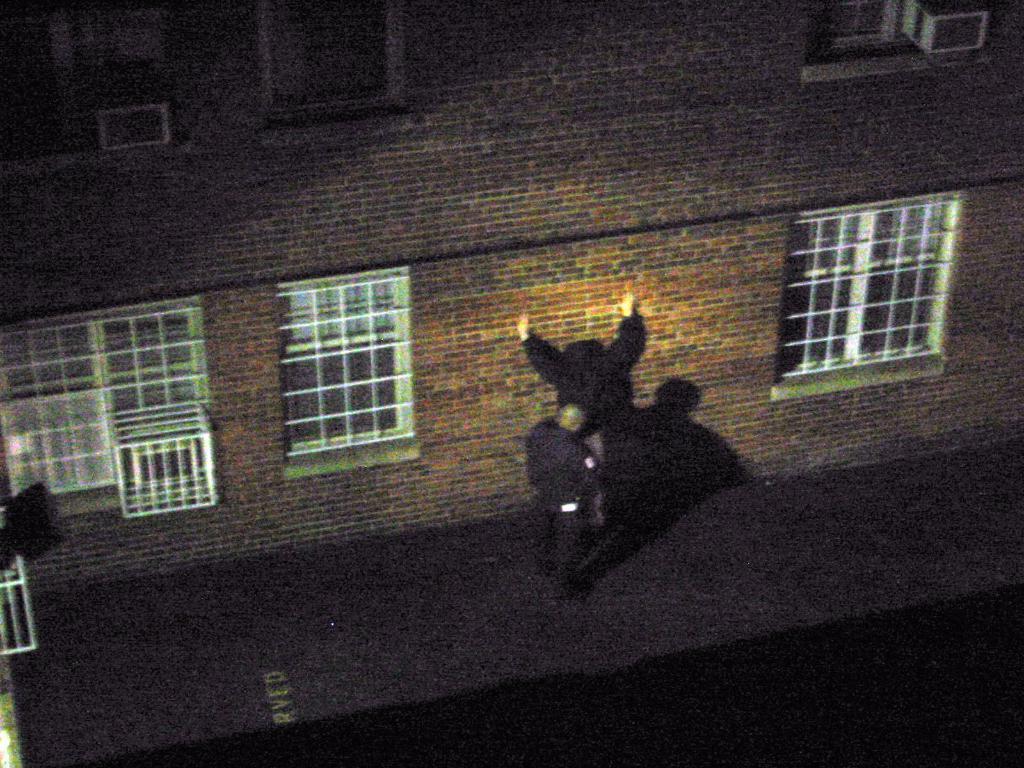Could you give a brief overview of what you see in this image? There is a person standing and we can see building and windows. We can see shadow of a person on the wall. 